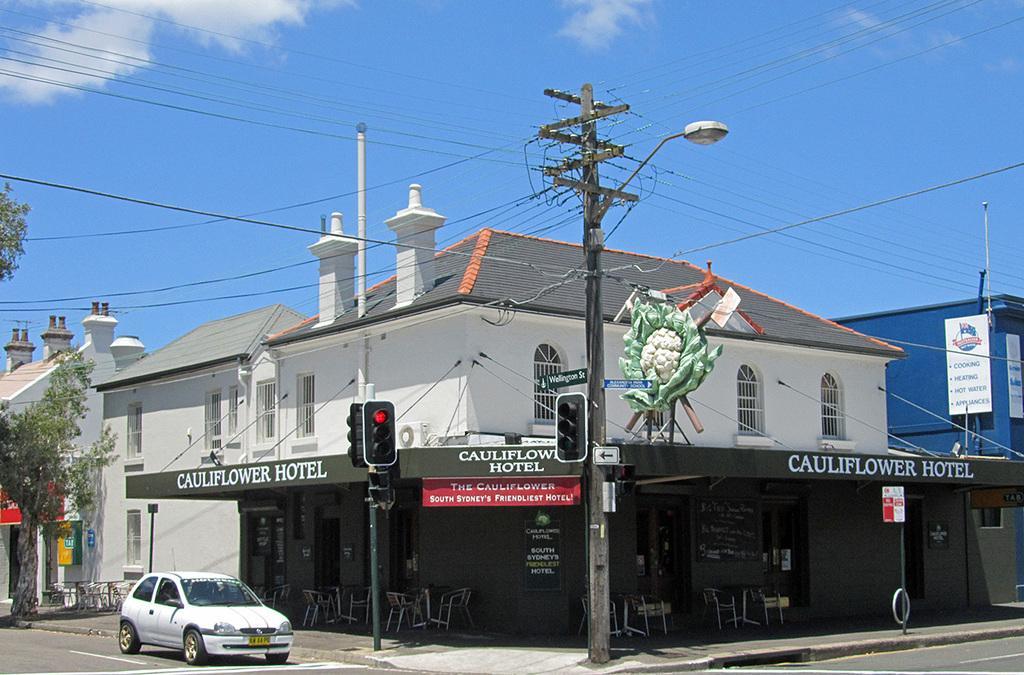How would you summarize this image in a sentence or two? In this picture I can see there is a junction and there is a pole with electric wires and there are a light, traffic lights and there is a tree at the left side, there are a few buildings and there are few windows and the sky is clear. 